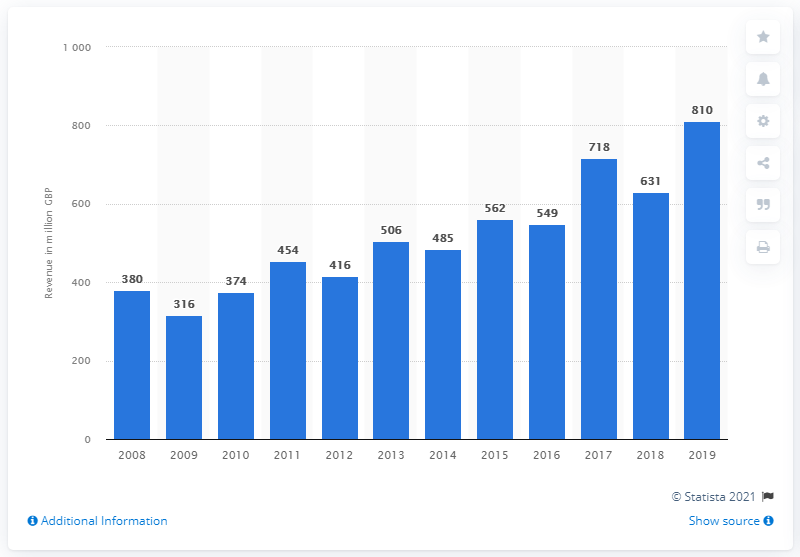Outline some significant characteristics in this image. In 2008, the annual revenue of museum activities in the UK began to grow. In 2019, the estimated total revenue from museum activities in the UK was approximately 810 million. 